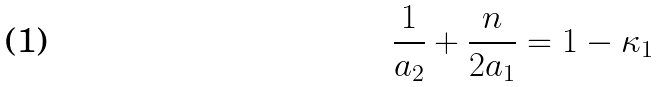Convert formula to latex. <formula><loc_0><loc_0><loc_500><loc_500>\frac { 1 } { a _ { 2 } } + \frac { n } { 2 a _ { 1 } } = 1 - \kappa _ { 1 }</formula> 